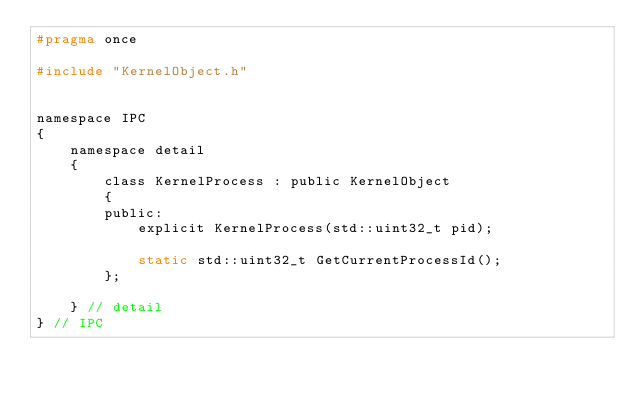Convert code to text. <code><loc_0><loc_0><loc_500><loc_500><_C_>#pragma once

#include "KernelObject.h"


namespace IPC
{
    namespace detail
    {
        class KernelProcess : public KernelObject
        {
        public:
            explicit KernelProcess(std::uint32_t pid);

            static std::uint32_t GetCurrentProcessId();
        };
        
    } // detail
} // IPC
</code> 